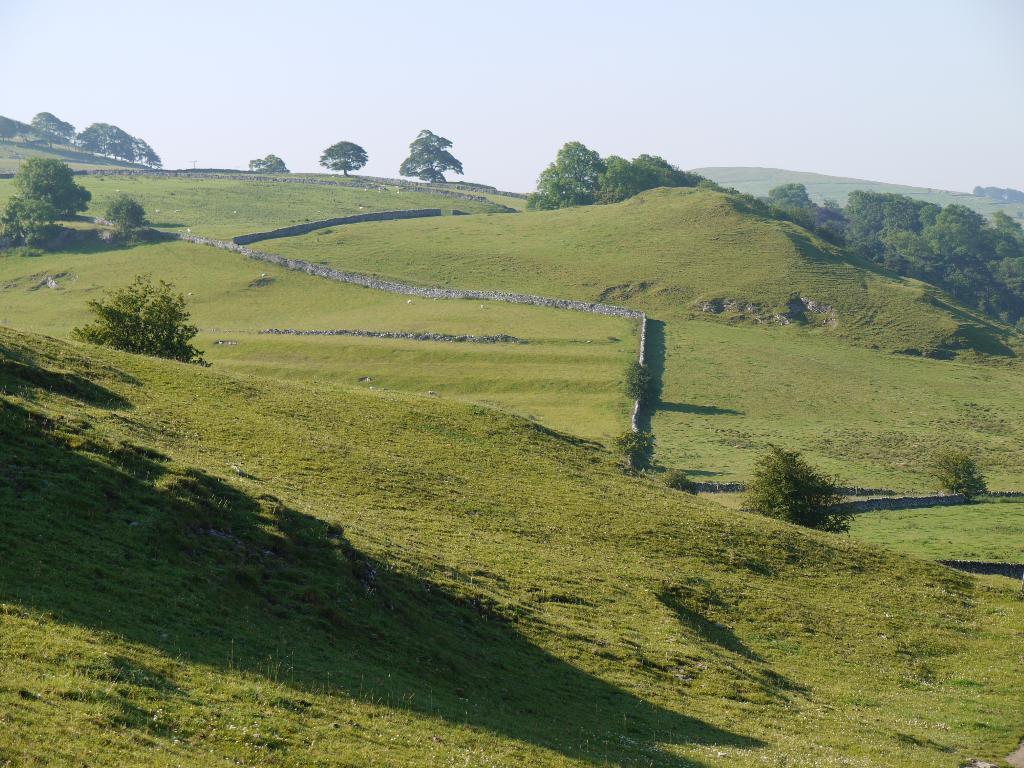Can you describe this image briefly? This picture is clicked outside. In the center we can see the ground is covered with the green grass and we can see the plants and some objects. In the background we can see the sky, hills and trees. 